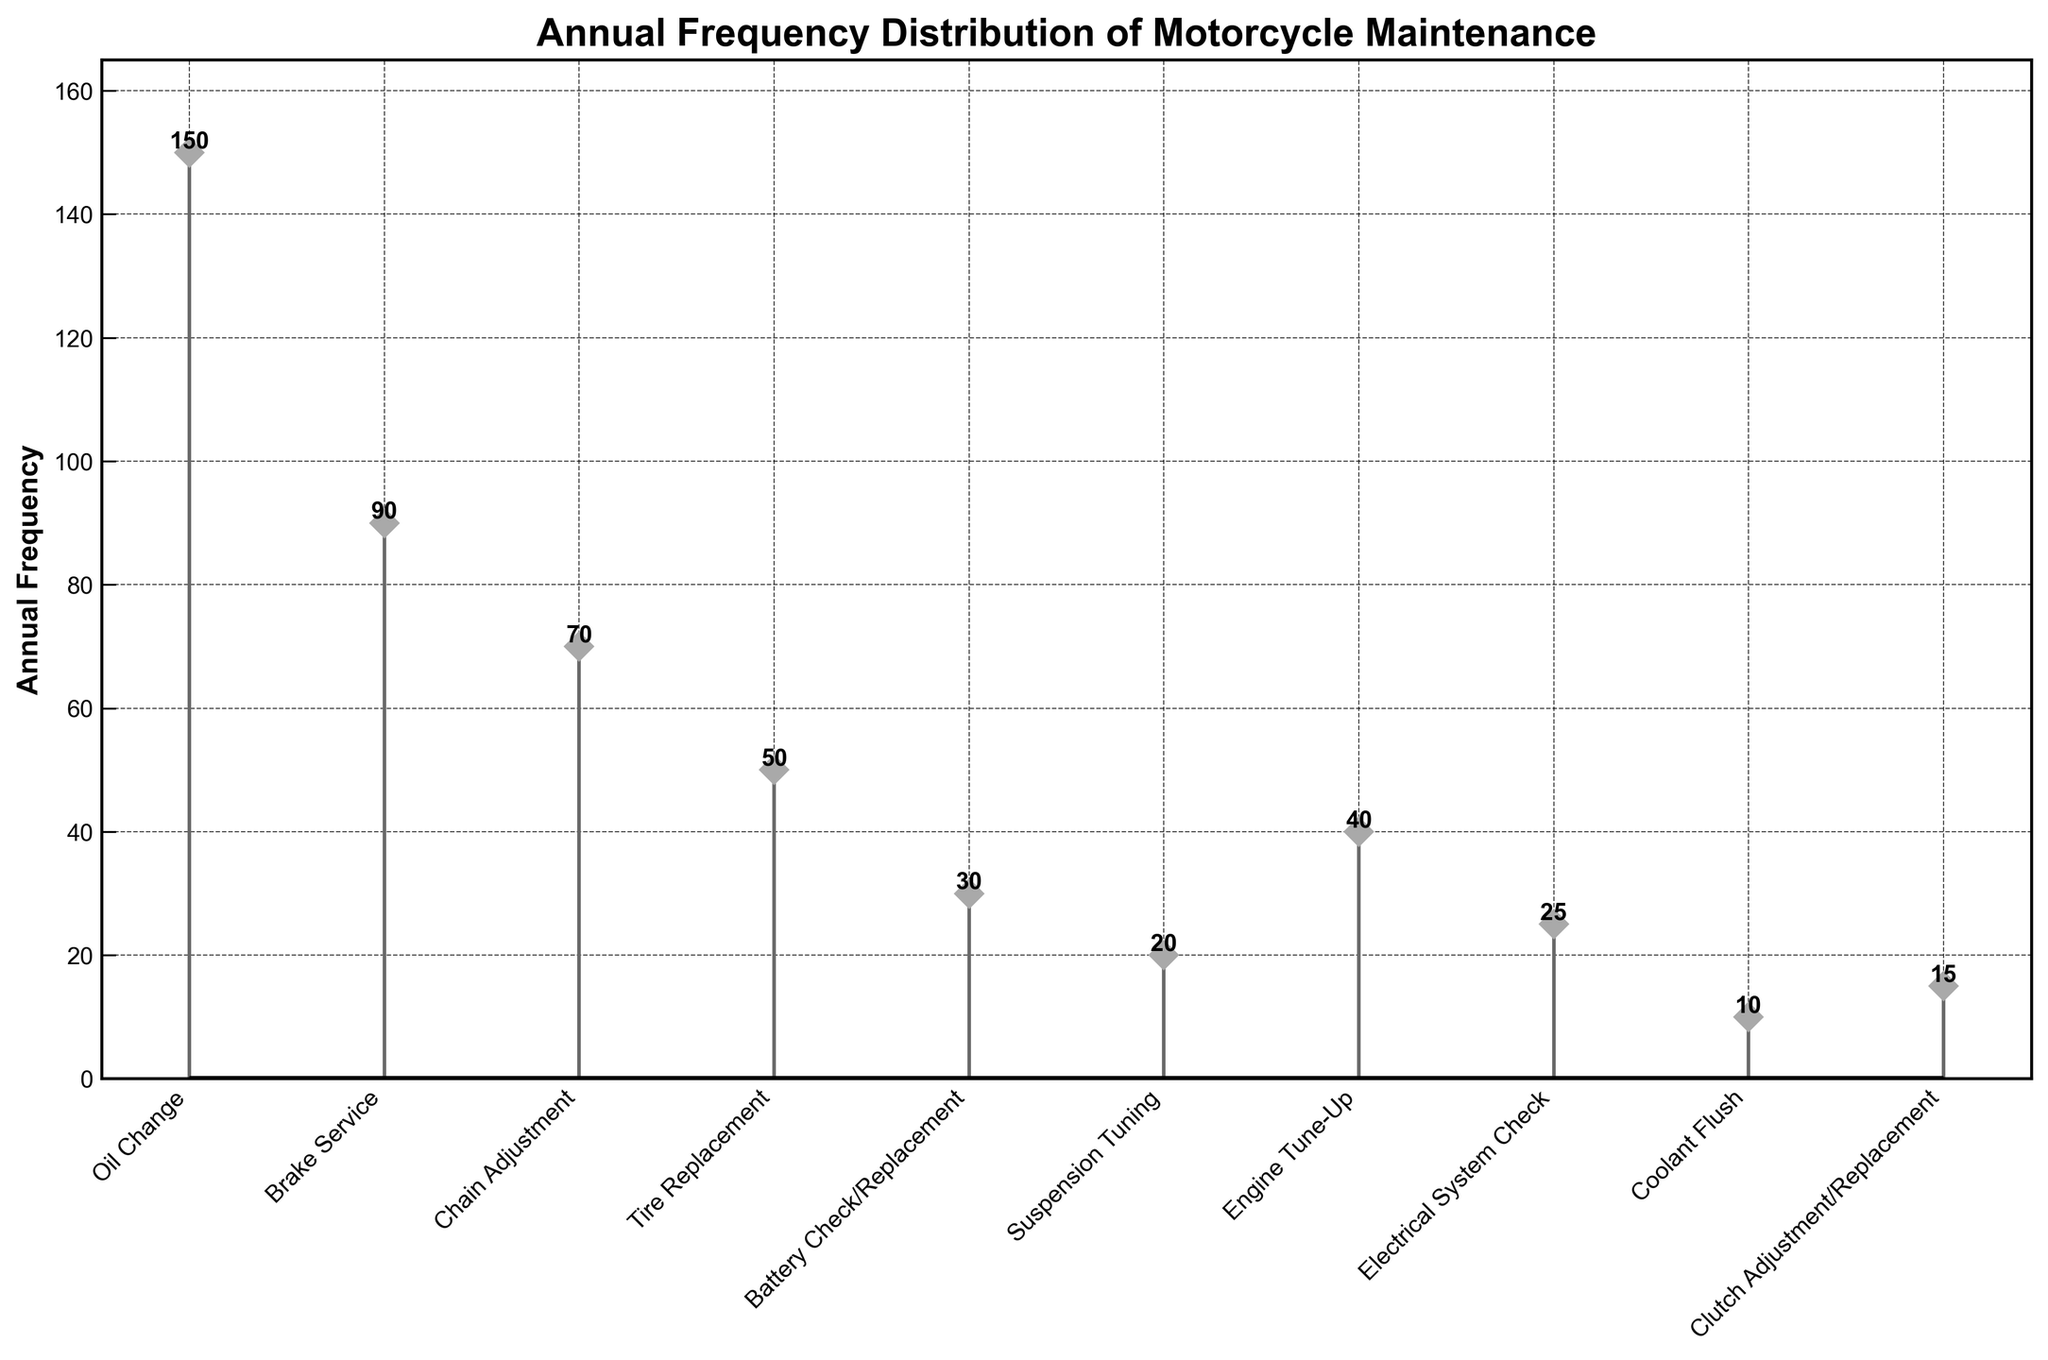What's the most frequent type of motorcycle maintenance? Look at the highest point in the stem plot and note which service type it corresponds to. That point is "Oil Change" with a frequency of 150.
Answer: Oil Change What is the combined annual frequency of Brake Service and Tire Replacement? First identify the frequencies for Brake Service and Tire Replacement, which are 90 and 50 respectively. Then sum them up: 90 + 50 = 140.
Answer: 140 Which service type has the lowest annual frequency? Find the shortest stem in the plot. The shortest stem corresponds to "Coolant Flush" with a frequency of 10.
Answer: Coolant Flush What is the difference in frequency between Battery Check/Replacement and Suspension Tuning? Identify the frequencies for Battery Check/Replacement and Suspension Tuning, which are 30 and 20 respectively. Subtract the smaller frequency from the larger: 30 - 20 = 10.
Answer: 10 How many service types have an annual frequency of 50 or higher? Count the number of stems in the plot that have a frequency of 50 or more. They are "Oil Change," "Brake Service," "Chain Adjustment," and "Tire Replacement." This makes 4 service types.
Answer: 4 What's the median annual frequency across all service types? List the frequencies in ascending order: 10, 15, 20, 25, 30, 40, 50, 70, 90, 150. With 10 data points, the median is the average of the 5th and 6th values: (30 + 40)/2 = 35.
Answer: 35 Which service type has an annual frequency closest to the average annual frequency of all services? Calculate the average frequency: Sum of all frequencies (150+90+70+50+30+20+40+25+10+15 = 500) divided by the number of service types (10) gives 500/10 = 50. "Tire Replacement" matches this value exactly.
Answer: Tire Replacement Which services have a frequency between 20 and 50? Identify all stems with a frequency in the range 20 to 50. These are "Battery Check/Replacement" (30), "Suspension Tuning" (20), "Engine Tune-Up" (40), and "Electrical System Check" (25).
Answer: Battery Check/Replacement, Suspension Tuning, Engine Tune-Up, Electrical System Check 